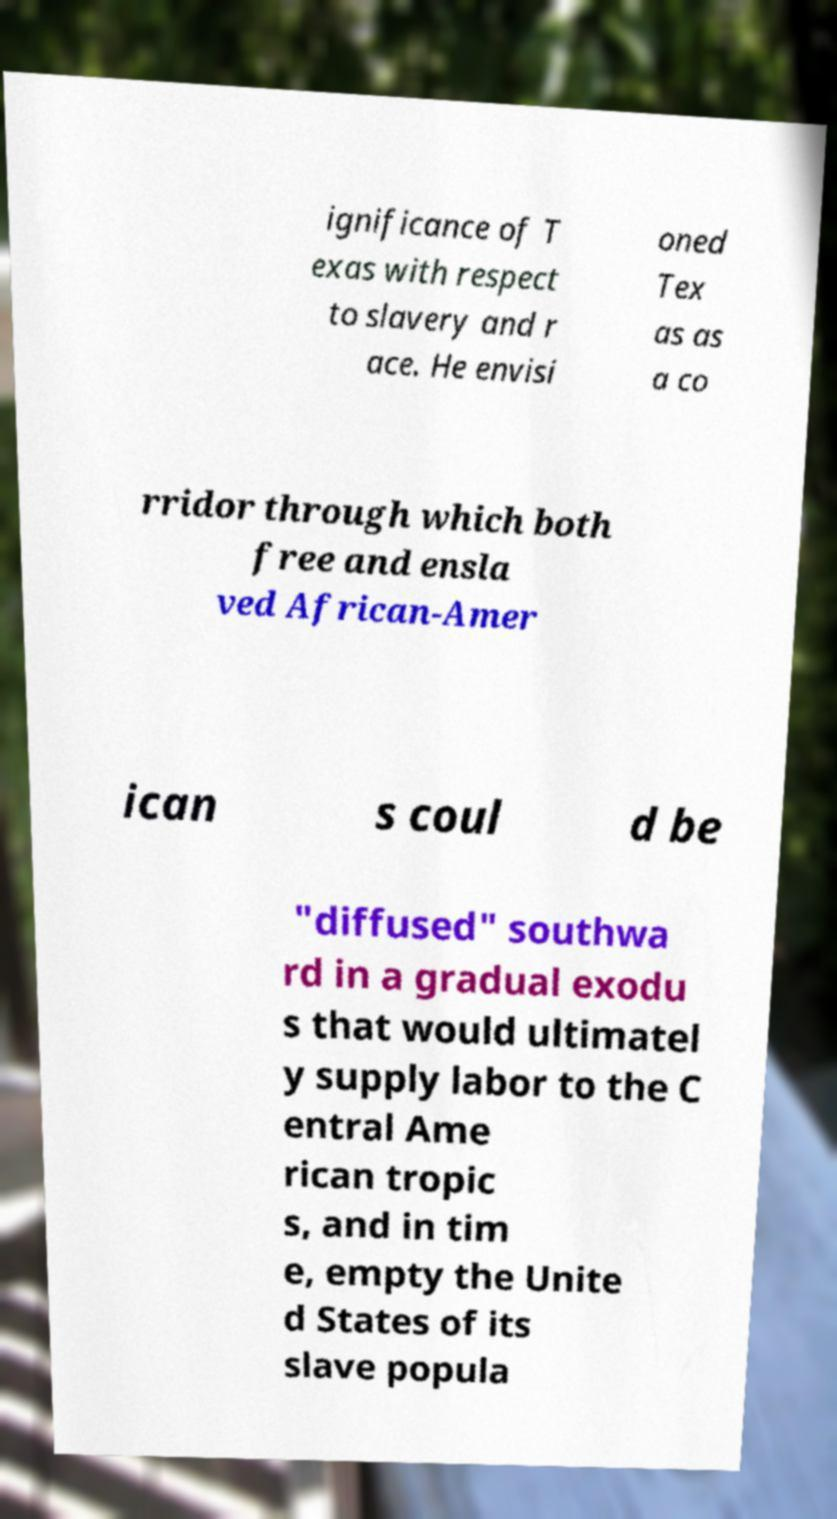Can you read and provide the text displayed in the image?This photo seems to have some interesting text. Can you extract and type it out for me? ignificance of T exas with respect to slavery and r ace. He envisi oned Tex as as a co rridor through which both free and ensla ved African-Amer ican s coul d be "diffused" southwa rd in a gradual exodu s that would ultimatel y supply labor to the C entral Ame rican tropic s, and in tim e, empty the Unite d States of its slave popula 